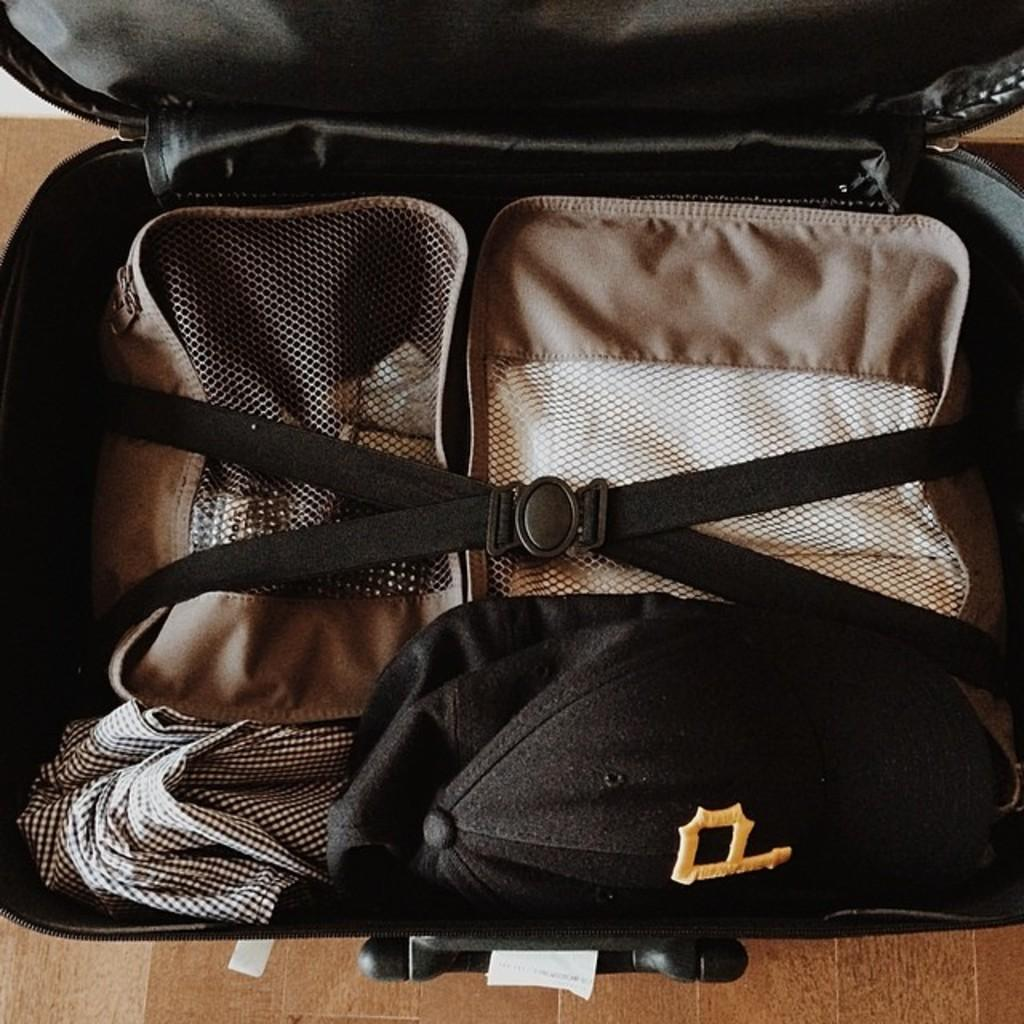What type of luggage is visible in the image? There is a black luggage in the image. Where is the luggage located? The luggage is placed on the ground. What is inside the luggage? There are two couches inside the luggage. How are the couches secured inside the luggage? There is a belt attached to the couches. What type of mask is visible on the couches inside the luggage? There is no mask visible on the couches inside the luggage. Are there any letters or messages written on the luggage? The provided facts do not mention any letters or messages written on the luggage. --- 